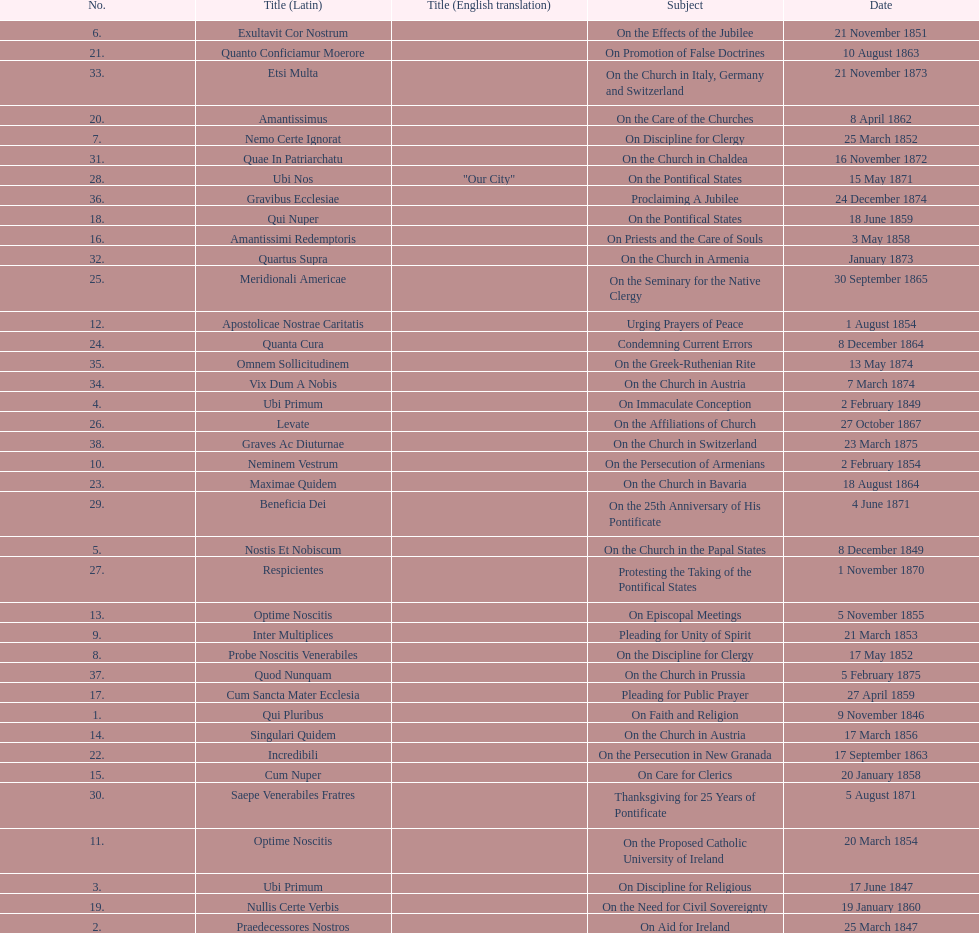What is the total number of title? 38. 